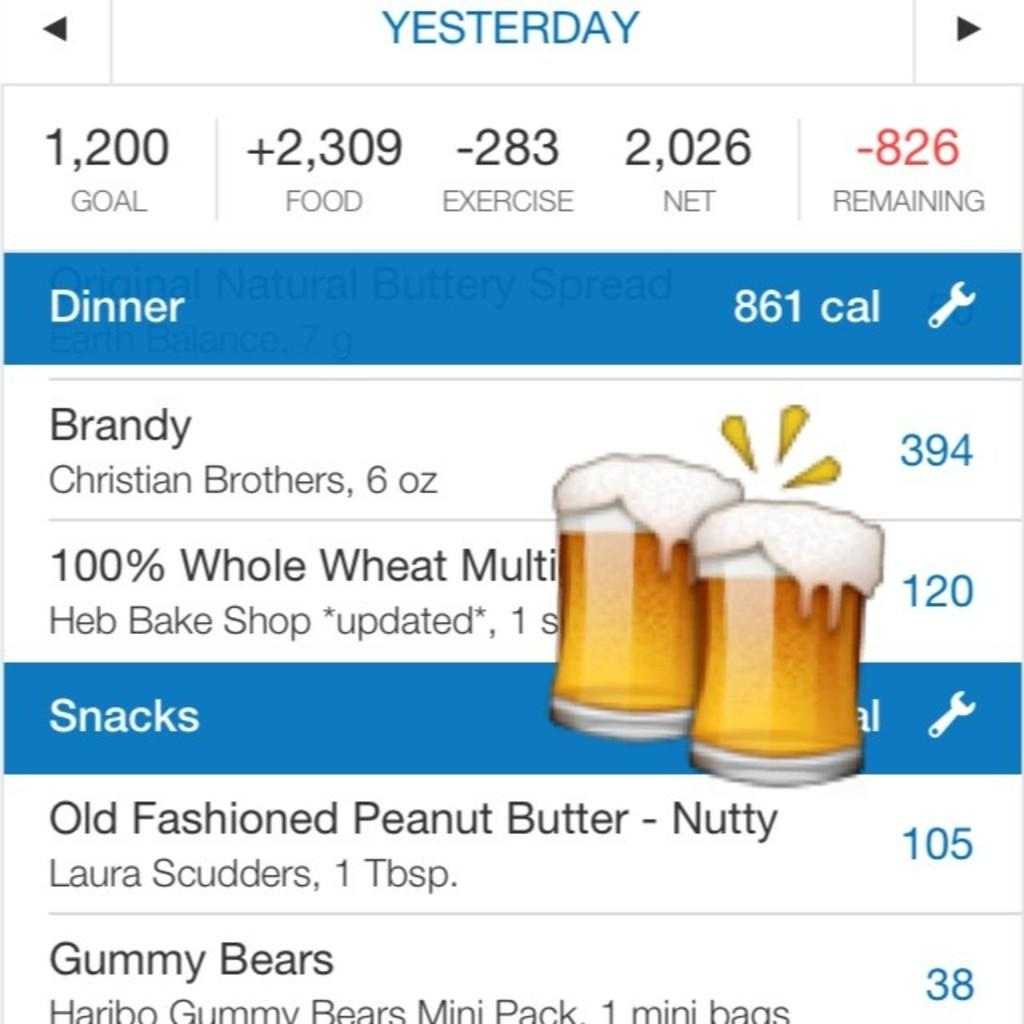Provide a one-sentence caption for the provided image. A listing of calories for various dinner and snack items including Brandy, gummy bears, and peanut butter, among others. 